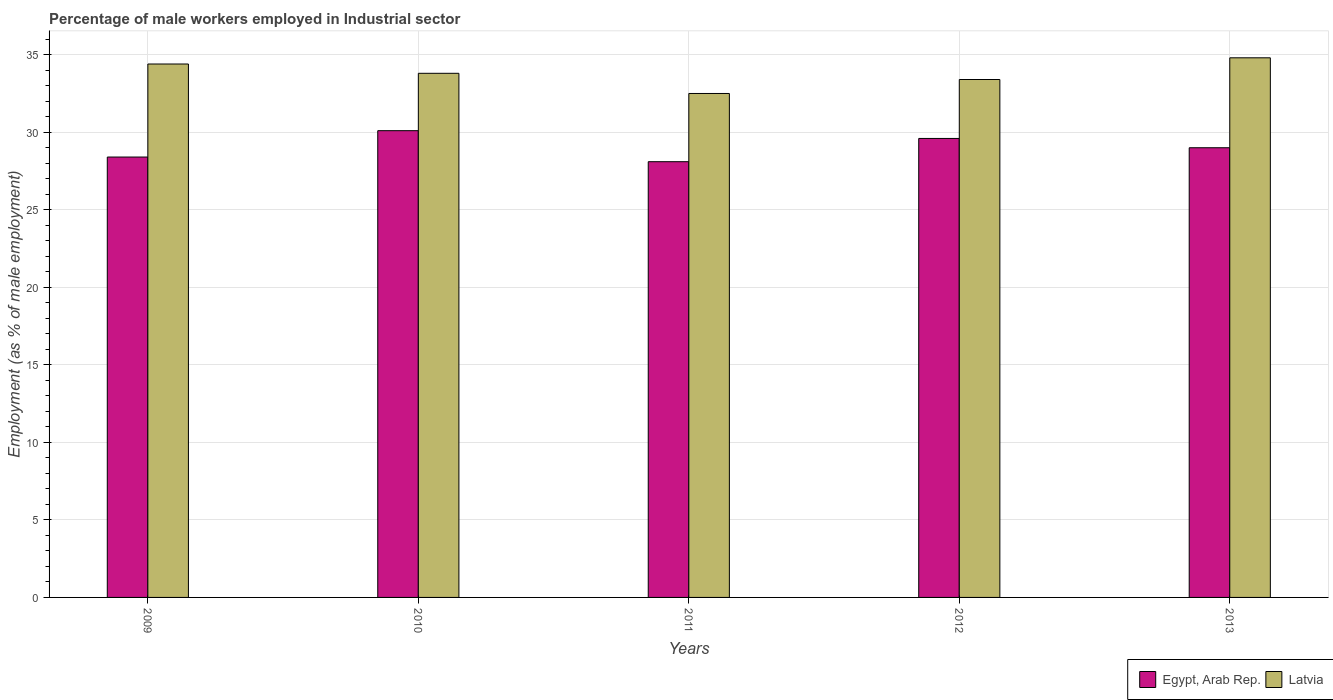Are the number of bars per tick equal to the number of legend labels?
Offer a terse response. Yes. Are the number of bars on each tick of the X-axis equal?
Keep it short and to the point. Yes. How many bars are there on the 5th tick from the left?
Your answer should be very brief. 2. In how many cases, is the number of bars for a given year not equal to the number of legend labels?
Provide a short and direct response. 0. What is the percentage of male workers employed in Industrial sector in Egypt, Arab Rep. in 2012?
Ensure brevity in your answer.  29.6. Across all years, what is the maximum percentage of male workers employed in Industrial sector in Latvia?
Offer a terse response. 34.8. Across all years, what is the minimum percentage of male workers employed in Industrial sector in Egypt, Arab Rep.?
Make the answer very short. 28.1. In which year was the percentage of male workers employed in Industrial sector in Latvia maximum?
Offer a terse response. 2013. What is the total percentage of male workers employed in Industrial sector in Latvia in the graph?
Give a very brief answer. 168.9. What is the difference between the percentage of male workers employed in Industrial sector in Egypt, Arab Rep. in 2012 and the percentage of male workers employed in Industrial sector in Latvia in 2013?
Your answer should be very brief. -5.2. What is the average percentage of male workers employed in Industrial sector in Latvia per year?
Provide a succinct answer. 33.78. In the year 2013, what is the difference between the percentage of male workers employed in Industrial sector in Egypt, Arab Rep. and percentage of male workers employed in Industrial sector in Latvia?
Your answer should be very brief. -5.8. In how many years, is the percentage of male workers employed in Industrial sector in Egypt, Arab Rep. greater than 23 %?
Your answer should be very brief. 5. What is the ratio of the percentage of male workers employed in Industrial sector in Latvia in 2010 to that in 2011?
Offer a terse response. 1.04. What is the difference between the highest and the second highest percentage of male workers employed in Industrial sector in Latvia?
Provide a succinct answer. 0.4. In how many years, is the percentage of male workers employed in Industrial sector in Egypt, Arab Rep. greater than the average percentage of male workers employed in Industrial sector in Egypt, Arab Rep. taken over all years?
Keep it short and to the point. 2. What does the 1st bar from the left in 2013 represents?
Give a very brief answer. Egypt, Arab Rep. What does the 1st bar from the right in 2011 represents?
Make the answer very short. Latvia. Are the values on the major ticks of Y-axis written in scientific E-notation?
Provide a short and direct response. No. Does the graph contain grids?
Keep it short and to the point. Yes. Where does the legend appear in the graph?
Your answer should be compact. Bottom right. How many legend labels are there?
Your answer should be very brief. 2. How are the legend labels stacked?
Give a very brief answer. Horizontal. What is the title of the graph?
Offer a very short reply. Percentage of male workers employed in Industrial sector. Does "Barbados" appear as one of the legend labels in the graph?
Your response must be concise. No. What is the label or title of the Y-axis?
Provide a succinct answer. Employment (as % of male employment). What is the Employment (as % of male employment) in Egypt, Arab Rep. in 2009?
Your response must be concise. 28.4. What is the Employment (as % of male employment) of Latvia in 2009?
Offer a terse response. 34.4. What is the Employment (as % of male employment) in Egypt, Arab Rep. in 2010?
Make the answer very short. 30.1. What is the Employment (as % of male employment) of Latvia in 2010?
Your response must be concise. 33.8. What is the Employment (as % of male employment) in Egypt, Arab Rep. in 2011?
Your answer should be compact. 28.1. What is the Employment (as % of male employment) in Latvia in 2011?
Offer a terse response. 32.5. What is the Employment (as % of male employment) of Egypt, Arab Rep. in 2012?
Your response must be concise. 29.6. What is the Employment (as % of male employment) of Latvia in 2012?
Offer a terse response. 33.4. What is the Employment (as % of male employment) in Latvia in 2013?
Offer a terse response. 34.8. Across all years, what is the maximum Employment (as % of male employment) of Egypt, Arab Rep.?
Keep it short and to the point. 30.1. Across all years, what is the maximum Employment (as % of male employment) in Latvia?
Offer a very short reply. 34.8. Across all years, what is the minimum Employment (as % of male employment) of Egypt, Arab Rep.?
Keep it short and to the point. 28.1. Across all years, what is the minimum Employment (as % of male employment) of Latvia?
Offer a terse response. 32.5. What is the total Employment (as % of male employment) of Egypt, Arab Rep. in the graph?
Your answer should be compact. 145.2. What is the total Employment (as % of male employment) in Latvia in the graph?
Keep it short and to the point. 168.9. What is the difference between the Employment (as % of male employment) of Egypt, Arab Rep. in 2009 and that in 2010?
Your answer should be very brief. -1.7. What is the difference between the Employment (as % of male employment) of Latvia in 2009 and that in 2010?
Make the answer very short. 0.6. What is the difference between the Employment (as % of male employment) of Latvia in 2009 and that in 2013?
Your response must be concise. -0.4. What is the difference between the Employment (as % of male employment) of Egypt, Arab Rep. in 2011 and that in 2012?
Make the answer very short. -1.5. What is the difference between the Employment (as % of male employment) in Egypt, Arab Rep. in 2011 and that in 2013?
Keep it short and to the point. -0.9. What is the difference between the Employment (as % of male employment) of Egypt, Arab Rep. in 2012 and that in 2013?
Provide a short and direct response. 0.6. What is the difference between the Employment (as % of male employment) of Egypt, Arab Rep. in 2009 and the Employment (as % of male employment) of Latvia in 2013?
Offer a terse response. -6.4. What is the difference between the Employment (as % of male employment) in Egypt, Arab Rep. in 2010 and the Employment (as % of male employment) in Latvia in 2012?
Keep it short and to the point. -3.3. What is the difference between the Employment (as % of male employment) of Egypt, Arab Rep. in 2010 and the Employment (as % of male employment) of Latvia in 2013?
Provide a succinct answer. -4.7. What is the difference between the Employment (as % of male employment) of Egypt, Arab Rep. in 2012 and the Employment (as % of male employment) of Latvia in 2013?
Keep it short and to the point. -5.2. What is the average Employment (as % of male employment) in Egypt, Arab Rep. per year?
Provide a short and direct response. 29.04. What is the average Employment (as % of male employment) of Latvia per year?
Offer a very short reply. 33.78. In the year 2013, what is the difference between the Employment (as % of male employment) of Egypt, Arab Rep. and Employment (as % of male employment) of Latvia?
Offer a very short reply. -5.8. What is the ratio of the Employment (as % of male employment) in Egypt, Arab Rep. in 2009 to that in 2010?
Provide a short and direct response. 0.94. What is the ratio of the Employment (as % of male employment) of Latvia in 2009 to that in 2010?
Keep it short and to the point. 1.02. What is the ratio of the Employment (as % of male employment) in Egypt, Arab Rep. in 2009 to that in 2011?
Offer a terse response. 1.01. What is the ratio of the Employment (as % of male employment) in Latvia in 2009 to that in 2011?
Offer a terse response. 1.06. What is the ratio of the Employment (as % of male employment) in Egypt, Arab Rep. in 2009 to that in 2012?
Your answer should be compact. 0.96. What is the ratio of the Employment (as % of male employment) of Latvia in 2009 to that in 2012?
Your answer should be compact. 1.03. What is the ratio of the Employment (as % of male employment) in Egypt, Arab Rep. in 2009 to that in 2013?
Your response must be concise. 0.98. What is the ratio of the Employment (as % of male employment) of Latvia in 2009 to that in 2013?
Give a very brief answer. 0.99. What is the ratio of the Employment (as % of male employment) in Egypt, Arab Rep. in 2010 to that in 2011?
Your response must be concise. 1.07. What is the ratio of the Employment (as % of male employment) of Latvia in 2010 to that in 2011?
Offer a very short reply. 1.04. What is the ratio of the Employment (as % of male employment) of Egypt, Arab Rep. in 2010 to that in 2012?
Provide a short and direct response. 1.02. What is the ratio of the Employment (as % of male employment) in Latvia in 2010 to that in 2012?
Provide a short and direct response. 1.01. What is the ratio of the Employment (as % of male employment) of Egypt, Arab Rep. in 2010 to that in 2013?
Provide a succinct answer. 1.04. What is the ratio of the Employment (as % of male employment) of Latvia in 2010 to that in 2013?
Make the answer very short. 0.97. What is the ratio of the Employment (as % of male employment) in Egypt, Arab Rep. in 2011 to that in 2012?
Keep it short and to the point. 0.95. What is the ratio of the Employment (as % of male employment) in Latvia in 2011 to that in 2012?
Keep it short and to the point. 0.97. What is the ratio of the Employment (as % of male employment) in Egypt, Arab Rep. in 2011 to that in 2013?
Your answer should be very brief. 0.97. What is the ratio of the Employment (as % of male employment) of Latvia in 2011 to that in 2013?
Offer a terse response. 0.93. What is the ratio of the Employment (as % of male employment) of Egypt, Arab Rep. in 2012 to that in 2013?
Give a very brief answer. 1.02. What is the ratio of the Employment (as % of male employment) of Latvia in 2012 to that in 2013?
Provide a short and direct response. 0.96. What is the difference between the highest and the second highest Employment (as % of male employment) of Egypt, Arab Rep.?
Offer a terse response. 0.5. What is the difference between the highest and the lowest Employment (as % of male employment) in Latvia?
Offer a very short reply. 2.3. 